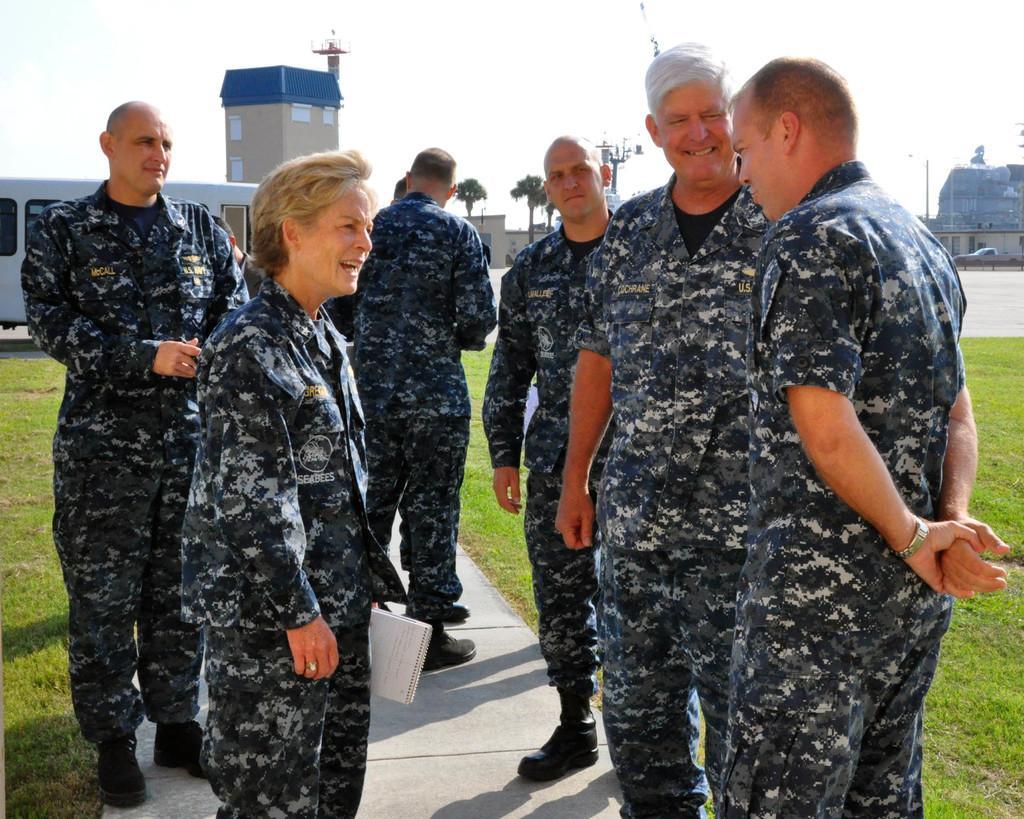Could you give a brief overview of what you see in this image? In this image I can see group of people are standing among them this woman is holding some objects. These people are wearing uniforms. In the background I can see buildings, trees, the grass and the sky. 